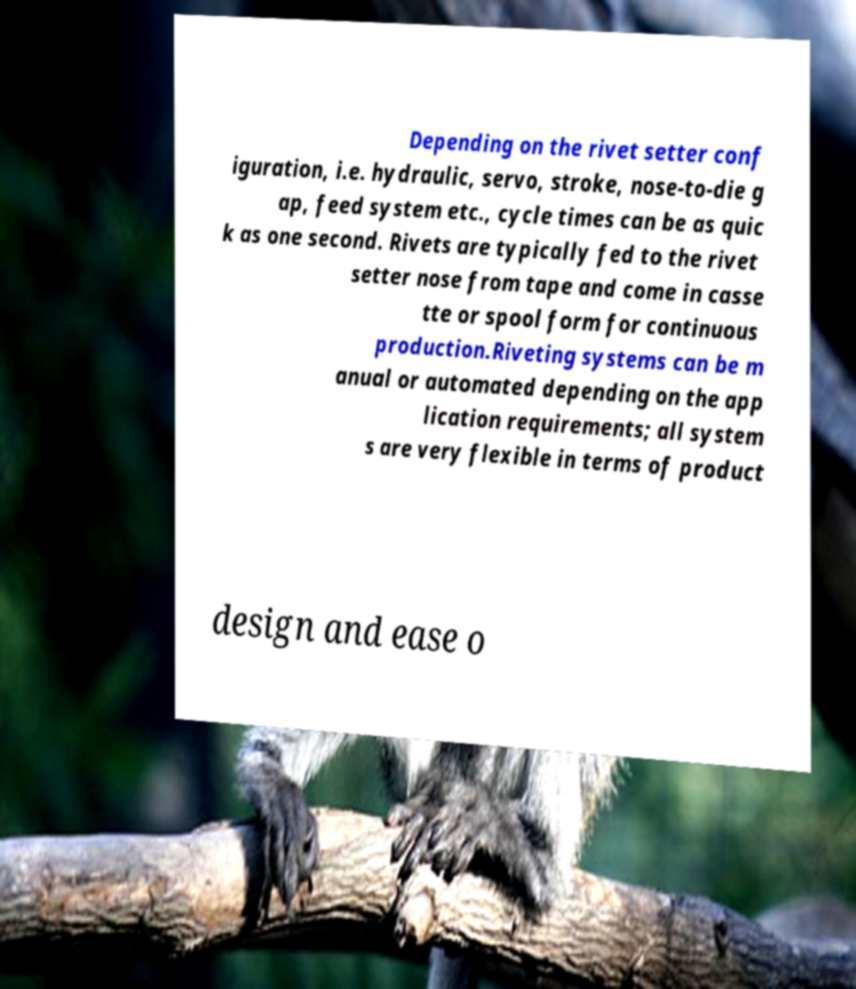I need the written content from this picture converted into text. Can you do that? Depending on the rivet setter conf iguration, i.e. hydraulic, servo, stroke, nose-to-die g ap, feed system etc., cycle times can be as quic k as one second. Rivets are typically fed to the rivet setter nose from tape and come in casse tte or spool form for continuous production.Riveting systems can be m anual or automated depending on the app lication requirements; all system s are very flexible in terms of product design and ease o 